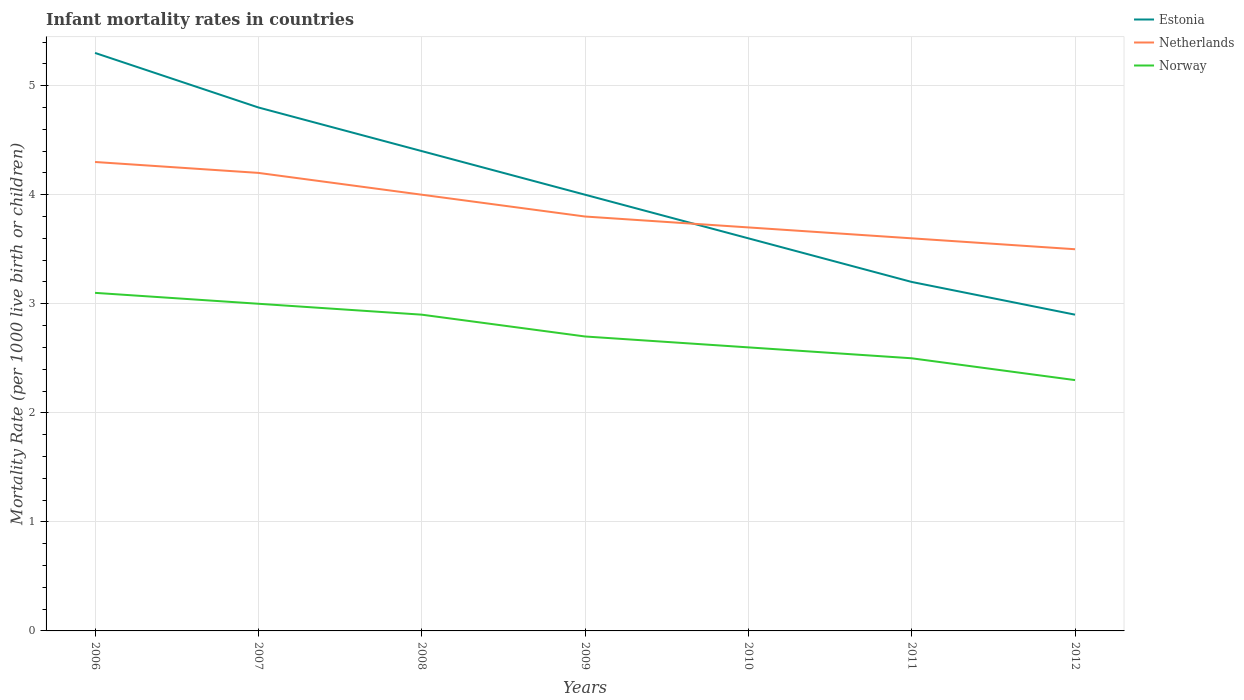How many different coloured lines are there?
Your answer should be very brief. 3. Across all years, what is the maximum infant mortality rate in Norway?
Your answer should be compact. 2.3. What is the total infant mortality rate in Norway in the graph?
Your answer should be compact. 0.2. What is the difference between two consecutive major ticks on the Y-axis?
Provide a succinct answer. 1. What is the title of the graph?
Provide a short and direct response. Infant mortality rates in countries. Does "Korea (Democratic)" appear as one of the legend labels in the graph?
Keep it short and to the point. No. What is the label or title of the X-axis?
Make the answer very short. Years. What is the label or title of the Y-axis?
Your answer should be compact. Mortality Rate (per 1000 live birth or children). What is the Mortality Rate (per 1000 live birth or children) of Estonia in 2006?
Offer a very short reply. 5.3. What is the Mortality Rate (per 1000 live birth or children) of Netherlands in 2006?
Keep it short and to the point. 4.3. What is the Mortality Rate (per 1000 live birth or children) of Estonia in 2007?
Give a very brief answer. 4.8. What is the Mortality Rate (per 1000 live birth or children) of Netherlands in 2007?
Provide a short and direct response. 4.2. What is the Mortality Rate (per 1000 live birth or children) of Netherlands in 2008?
Keep it short and to the point. 4. What is the Mortality Rate (per 1000 live birth or children) of Norway in 2008?
Provide a succinct answer. 2.9. What is the Mortality Rate (per 1000 live birth or children) of Netherlands in 2009?
Keep it short and to the point. 3.8. What is the Mortality Rate (per 1000 live birth or children) in Estonia in 2010?
Offer a terse response. 3.6. What is the Mortality Rate (per 1000 live birth or children) of Netherlands in 2010?
Your answer should be compact. 3.7. What is the Mortality Rate (per 1000 live birth or children) of Norway in 2010?
Provide a short and direct response. 2.6. What is the Mortality Rate (per 1000 live birth or children) in Estonia in 2011?
Provide a succinct answer. 3.2. What is the Mortality Rate (per 1000 live birth or children) in Netherlands in 2012?
Give a very brief answer. 3.5. What is the Mortality Rate (per 1000 live birth or children) in Norway in 2012?
Offer a very short reply. 2.3. Across all years, what is the maximum Mortality Rate (per 1000 live birth or children) in Norway?
Your answer should be very brief. 3.1. Across all years, what is the minimum Mortality Rate (per 1000 live birth or children) of Norway?
Give a very brief answer. 2.3. What is the total Mortality Rate (per 1000 live birth or children) of Estonia in the graph?
Give a very brief answer. 28.2. What is the total Mortality Rate (per 1000 live birth or children) of Netherlands in the graph?
Provide a succinct answer. 27.1. What is the difference between the Mortality Rate (per 1000 live birth or children) of Estonia in 2006 and that in 2007?
Provide a succinct answer. 0.5. What is the difference between the Mortality Rate (per 1000 live birth or children) of Netherlands in 2006 and that in 2007?
Offer a terse response. 0.1. What is the difference between the Mortality Rate (per 1000 live birth or children) in Estonia in 2006 and that in 2008?
Provide a short and direct response. 0.9. What is the difference between the Mortality Rate (per 1000 live birth or children) of Estonia in 2006 and that in 2009?
Give a very brief answer. 1.3. What is the difference between the Mortality Rate (per 1000 live birth or children) of Netherlands in 2006 and that in 2009?
Keep it short and to the point. 0.5. What is the difference between the Mortality Rate (per 1000 live birth or children) in Netherlands in 2006 and that in 2010?
Provide a short and direct response. 0.6. What is the difference between the Mortality Rate (per 1000 live birth or children) in Norway in 2006 and that in 2010?
Your response must be concise. 0.5. What is the difference between the Mortality Rate (per 1000 live birth or children) in Estonia in 2006 and that in 2011?
Ensure brevity in your answer.  2.1. What is the difference between the Mortality Rate (per 1000 live birth or children) in Norway in 2006 and that in 2011?
Provide a short and direct response. 0.6. What is the difference between the Mortality Rate (per 1000 live birth or children) of Norway in 2006 and that in 2012?
Offer a terse response. 0.8. What is the difference between the Mortality Rate (per 1000 live birth or children) of Estonia in 2007 and that in 2008?
Offer a terse response. 0.4. What is the difference between the Mortality Rate (per 1000 live birth or children) of Netherlands in 2007 and that in 2008?
Your response must be concise. 0.2. What is the difference between the Mortality Rate (per 1000 live birth or children) of Norway in 2007 and that in 2008?
Keep it short and to the point. 0.1. What is the difference between the Mortality Rate (per 1000 live birth or children) of Estonia in 2007 and that in 2009?
Your response must be concise. 0.8. What is the difference between the Mortality Rate (per 1000 live birth or children) of Netherlands in 2007 and that in 2009?
Your answer should be very brief. 0.4. What is the difference between the Mortality Rate (per 1000 live birth or children) in Estonia in 2007 and that in 2010?
Offer a very short reply. 1.2. What is the difference between the Mortality Rate (per 1000 live birth or children) in Netherlands in 2007 and that in 2010?
Make the answer very short. 0.5. What is the difference between the Mortality Rate (per 1000 live birth or children) of Netherlands in 2007 and that in 2011?
Your response must be concise. 0.6. What is the difference between the Mortality Rate (per 1000 live birth or children) in Estonia in 2007 and that in 2012?
Ensure brevity in your answer.  1.9. What is the difference between the Mortality Rate (per 1000 live birth or children) of Norway in 2007 and that in 2012?
Your answer should be compact. 0.7. What is the difference between the Mortality Rate (per 1000 live birth or children) of Norway in 2008 and that in 2009?
Your response must be concise. 0.2. What is the difference between the Mortality Rate (per 1000 live birth or children) of Estonia in 2008 and that in 2011?
Your answer should be compact. 1.2. What is the difference between the Mortality Rate (per 1000 live birth or children) in Netherlands in 2008 and that in 2011?
Make the answer very short. 0.4. What is the difference between the Mortality Rate (per 1000 live birth or children) in Norway in 2008 and that in 2011?
Ensure brevity in your answer.  0.4. What is the difference between the Mortality Rate (per 1000 live birth or children) of Estonia in 2008 and that in 2012?
Give a very brief answer. 1.5. What is the difference between the Mortality Rate (per 1000 live birth or children) in Netherlands in 2009 and that in 2010?
Your response must be concise. 0.1. What is the difference between the Mortality Rate (per 1000 live birth or children) of Netherlands in 2009 and that in 2011?
Your response must be concise. 0.2. What is the difference between the Mortality Rate (per 1000 live birth or children) in Norway in 2009 and that in 2011?
Your answer should be compact. 0.2. What is the difference between the Mortality Rate (per 1000 live birth or children) of Estonia in 2009 and that in 2012?
Ensure brevity in your answer.  1.1. What is the difference between the Mortality Rate (per 1000 live birth or children) in Norway in 2009 and that in 2012?
Ensure brevity in your answer.  0.4. What is the difference between the Mortality Rate (per 1000 live birth or children) of Netherlands in 2010 and that in 2011?
Your answer should be compact. 0.1. What is the difference between the Mortality Rate (per 1000 live birth or children) of Estonia in 2010 and that in 2012?
Provide a succinct answer. 0.7. What is the difference between the Mortality Rate (per 1000 live birth or children) in Netherlands in 2010 and that in 2012?
Give a very brief answer. 0.2. What is the difference between the Mortality Rate (per 1000 live birth or children) in Estonia in 2011 and that in 2012?
Your answer should be very brief. 0.3. What is the difference between the Mortality Rate (per 1000 live birth or children) in Netherlands in 2011 and that in 2012?
Give a very brief answer. 0.1. What is the difference between the Mortality Rate (per 1000 live birth or children) of Estonia in 2006 and the Mortality Rate (per 1000 live birth or children) of Netherlands in 2008?
Ensure brevity in your answer.  1.3. What is the difference between the Mortality Rate (per 1000 live birth or children) of Estonia in 2006 and the Mortality Rate (per 1000 live birth or children) of Norway in 2009?
Make the answer very short. 2.6. What is the difference between the Mortality Rate (per 1000 live birth or children) of Netherlands in 2006 and the Mortality Rate (per 1000 live birth or children) of Norway in 2009?
Your response must be concise. 1.6. What is the difference between the Mortality Rate (per 1000 live birth or children) in Estonia in 2006 and the Mortality Rate (per 1000 live birth or children) in Norway in 2010?
Offer a terse response. 2.7. What is the difference between the Mortality Rate (per 1000 live birth or children) in Netherlands in 2006 and the Mortality Rate (per 1000 live birth or children) in Norway in 2010?
Your answer should be compact. 1.7. What is the difference between the Mortality Rate (per 1000 live birth or children) in Estonia in 2006 and the Mortality Rate (per 1000 live birth or children) in Netherlands in 2011?
Keep it short and to the point. 1.7. What is the difference between the Mortality Rate (per 1000 live birth or children) in Netherlands in 2006 and the Mortality Rate (per 1000 live birth or children) in Norway in 2011?
Give a very brief answer. 1.8. What is the difference between the Mortality Rate (per 1000 live birth or children) in Estonia in 2006 and the Mortality Rate (per 1000 live birth or children) in Netherlands in 2012?
Offer a terse response. 1.8. What is the difference between the Mortality Rate (per 1000 live birth or children) in Estonia in 2006 and the Mortality Rate (per 1000 live birth or children) in Norway in 2012?
Provide a succinct answer. 3. What is the difference between the Mortality Rate (per 1000 live birth or children) of Estonia in 2007 and the Mortality Rate (per 1000 live birth or children) of Norway in 2008?
Ensure brevity in your answer.  1.9. What is the difference between the Mortality Rate (per 1000 live birth or children) of Netherlands in 2007 and the Mortality Rate (per 1000 live birth or children) of Norway in 2009?
Your answer should be very brief. 1.5. What is the difference between the Mortality Rate (per 1000 live birth or children) in Estonia in 2007 and the Mortality Rate (per 1000 live birth or children) in Netherlands in 2010?
Provide a short and direct response. 1.1. What is the difference between the Mortality Rate (per 1000 live birth or children) of Estonia in 2007 and the Mortality Rate (per 1000 live birth or children) of Norway in 2010?
Provide a short and direct response. 2.2. What is the difference between the Mortality Rate (per 1000 live birth or children) of Estonia in 2007 and the Mortality Rate (per 1000 live birth or children) of Netherlands in 2011?
Make the answer very short. 1.2. What is the difference between the Mortality Rate (per 1000 live birth or children) of Netherlands in 2007 and the Mortality Rate (per 1000 live birth or children) of Norway in 2011?
Make the answer very short. 1.7. What is the difference between the Mortality Rate (per 1000 live birth or children) in Estonia in 2007 and the Mortality Rate (per 1000 live birth or children) in Netherlands in 2012?
Provide a short and direct response. 1.3. What is the difference between the Mortality Rate (per 1000 live birth or children) in Estonia in 2007 and the Mortality Rate (per 1000 live birth or children) in Norway in 2012?
Provide a short and direct response. 2.5. What is the difference between the Mortality Rate (per 1000 live birth or children) of Netherlands in 2008 and the Mortality Rate (per 1000 live birth or children) of Norway in 2009?
Ensure brevity in your answer.  1.3. What is the difference between the Mortality Rate (per 1000 live birth or children) of Estonia in 2008 and the Mortality Rate (per 1000 live birth or children) of Netherlands in 2010?
Offer a terse response. 0.7. What is the difference between the Mortality Rate (per 1000 live birth or children) of Estonia in 2008 and the Mortality Rate (per 1000 live birth or children) of Norway in 2010?
Make the answer very short. 1.8. What is the difference between the Mortality Rate (per 1000 live birth or children) in Netherlands in 2008 and the Mortality Rate (per 1000 live birth or children) in Norway in 2010?
Offer a terse response. 1.4. What is the difference between the Mortality Rate (per 1000 live birth or children) of Estonia in 2008 and the Mortality Rate (per 1000 live birth or children) of Norway in 2011?
Your response must be concise. 1.9. What is the difference between the Mortality Rate (per 1000 live birth or children) of Netherlands in 2008 and the Mortality Rate (per 1000 live birth or children) of Norway in 2011?
Provide a short and direct response. 1.5. What is the difference between the Mortality Rate (per 1000 live birth or children) in Estonia in 2008 and the Mortality Rate (per 1000 live birth or children) in Netherlands in 2012?
Provide a short and direct response. 0.9. What is the difference between the Mortality Rate (per 1000 live birth or children) in Netherlands in 2008 and the Mortality Rate (per 1000 live birth or children) in Norway in 2012?
Provide a succinct answer. 1.7. What is the difference between the Mortality Rate (per 1000 live birth or children) of Estonia in 2009 and the Mortality Rate (per 1000 live birth or children) of Netherlands in 2011?
Provide a short and direct response. 0.4. What is the difference between the Mortality Rate (per 1000 live birth or children) in Netherlands in 2009 and the Mortality Rate (per 1000 live birth or children) in Norway in 2011?
Keep it short and to the point. 1.3. What is the difference between the Mortality Rate (per 1000 live birth or children) in Estonia in 2009 and the Mortality Rate (per 1000 live birth or children) in Norway in 2012?
Your answer should be very brief. 1.7. What is the difference between the Mortality Rate (per 1000 live birth or children) of Netherlands in 2009 and the Mortality Rate (per 1000 live birth or children) of Norway in 2012?
Offer a terse response. 1.5. What is the difference between the Mortality Rate (per 1000 live birth or children) in Netherlands in 2010 and the Mortality Rate (per 1000 live birth or children) in Norway in 2011?
Ensure brevity in your answer.  1.2. What is the difference between the Mortality Rate (per 1000 live birth or children) of Estonia in 2010 and the Mortality Rate (per 1000 live birth or children) of Netherlands in 2012?
Offer a terse response. 0.1. What is the difference between the Mortality Rate (per 1000 live birth or children) in Netherlands in 2010 and the Mortality Rate (per 1000 live birth or children) in Norway in 2012?
Provide a succinct answer. 1.4. What is the difference between the Mortality Rate (per 1000 live birth or children) of Estonia in 2011 and the Mortality Rate (per 1000 live birth or children) of Norway in 2012?
Ensure brevity in your answer.  0.9. What is the difference between the Mortality Rate (per 1000 live birth or children) of Netherlands in 2011 and the Mortality Rate (per 1000 live birth or children) of Norway in 2012?
Give a very brief answer. 1.3. What is the average Mortality Rate (per 1000 live birth or children) of Estonia per year?
Provide a short and direct response. 4.03. What is the average Mortality Rate (per 1000 live birth or children) in Netherlands per year?
Your response must be concise. 3.87. What is the average Mortality Rate (per 1000 live birth or children) of Norway per year?
Your answer should be compact. 2.73. In the year 2007, what is the difference between the Mortality Rate (per 1000 live birth or children) of Estonia and Mortality Rate (per 1000 live birth or children) of Netherlands?
Provide a succinct answer. 0.6. In the year 2007, what is the difference between the Mortality Rate (per 1000 live birth or children) of Estonia and Mortality Rate (per 1000 live birth or children) of Norway?
Keep it short and to the point. 1.8. In the year 2007, what is the difference between the Mortality Rate (per 1000 live birth or children) in Netherlands and Mortality Rate (per 1000 live birth or children) in Norway?
Ensure brevity in your answer.  1.2. In the year 2008, what is the difference between the Mortality Rate (per 1000 live birth or children) in Estonia and Mortality Rate (per 1000 live birth or children) in Netherlands?
Your answer should be very brief. 0.4. In the year 2008, what is the difference between the Mortality Rate (per 1000 live birth or children) of Estonia and Mortality Rate (per 1000 live birth or children) of Norway?
Your response must be concise. 1.5. In the year 2008, what is the difference between the Mortality Rate (per 1000 live birth or children) in Netherlands and Mortality Rate (per 1000 live birth or children) in Norway?
Your answer should be compact. 1.1. In the year 2010, what is the difference between the Mortality Rate (per 1000 live birth or children) in Netherlands and Mortality Rate (per 1000 live birth or children) in Norway?
Offer a terse response. 1.1. In the year 2011, what is the difference between the Mortality Rate (per 1000 live birth or children) in Estonia and Mortality Rate (per 1000 live birth or children) in Norway?
Offer a very short reply. 0.7. In the year 2011, what is the difference between the Mortality Rate (per 1000 live birth or children) in Netherlands and Mortality Rate (per 1000 live birth or children) in Norway?
Ensure brevity in your answer.  1.1. In the year 2012, what is the difference between the Mortality Rate (per 1000 live birth or children) in Estonia and Mortality Rate (per 1000 live birth or children) in Norway?
Your answer should be very brief. 0.6. What is the ratio of the Mortality Rate (per 1000 live birth or children) in Estonia in 2006 to that in 2007?
Offer a terse response. 1.1. What is the ratio of the Mortality Rate (per 1000 live birth or children) of Netherlands in 2006 to that in 2007?
Keep it short and to the point. 1.02. What is the ratio of the Mortality Rate (per 1000 live birth or children) of Norway in 2006 to that in 2007?
Your answer should be compact. 1.03. What is the ratio of the Mortality Rate (per 1000 live birth or children) in Estonia in 2006 to that in 2008?
Offer a very short reply. 1.2. What is the ratio of the Mortality Rate (per 1000 live birth or children) of Netherlands in 2006 to that in 2008?
Provide a short and direct response. 1.07. What is the ratio of the Mortality Rate (per 1000 live birth or children) of Norway in 2006 to that in 2008?
Offer a terse response. 1.07. What is the ratio of the Mortality Rate (per 1000 live birth or children) in Estonia in 2006 to that in 2009?
Give a very brief answer. 1.32. What is the ratio of the Mortality Rate (per 1000 live birth or children) in Netherlands in 2006 to that in 2009?
Your response must be concise. 1.13. What is the ratio of the Mortality Rate (per 1000 live birth or children) of Norway in 2006 to that in 2009?
Provide a short and direct response. 1.15. What is the ratio of the Mortality Rate (per 1000 live birth or children) of Estonia in 2006 to that in 2010?
Provide a succinct answer. 1.47. What is the ratio of the Mortality Rate (per 1000 live birth or children) in Netherlands in 2006 to that in 2010?
Your answer should be compact. 1.16. What is the ratio of the Mortality Rate (per 1000 live birth or children) of Norway in 2006 to that in 2010?
Provide a succinct answer. 1.19. What is the ratio of the Mortality Rate (per 1000 live birth or children) of Estonia in 2006 to that in 2011?
Offer a terse response. 1.66. What is the ratio of the Mortality Rate (per 1000 live birth or children) of Netherlands in 2006 to that in 2011?
Provide a succinct answer. 1.19. What is the ratio of the Mortality Rate (per 1000 live birth or children) of Norway in 2006 to that in 2011?
Offer a terse response. 1.24. What is the ratio of the Mortality Rate (per 1000 live birth or children) of Estonia in 2006 to that in 2012?
Ensure brevity in your answer.  1.83. What is the ratio of the Mortality Rate (per 1000 live birth or children) in Netherlands in 2006 to that in 2012?
Your response must be concise. 1.23. What is the ratio of the Mortality Rate (per 1000 live birth or children) in Norway in 2006 to that in 2012?
Keep it short and to the point. 1.35. What is the ratio of the Mortality Rate (per 1000 live birth or children) of Netherlands in 2007 to that in 2008?
Ensure brevity in your answer.  1.05. What is the ratio of the Mortality Rate (per 1000 live birth or children) in Norway in 2007 to that in 2008?
Your response must be concise. 1.03. What is the ratio of the Mortality Rate (per 1000 live birth or children) of Estonia in 2007 to that in 2009?
Your answer should be very brief. 1.2. What is the ratio of the Mortality Rate (per 1000 live birth or children) in Netherlands in 2007 to that in 2009?
Provide a short and direct response. 1.11. What is the ratio of the Mortality Rate (per 1000 live birth or children) in Netherlands in 2007 to that in 2010?
Your answer should be compact. 1.14. What is the ratio of the Mortality Rate (per 1000 live birth or children) in Norway in 2007 to that in 2010?
Ensure brevity in your answer.  1.15. What is the ratio of the Mortality Rate (per 1000 live birth or children) of Netherlands in 2007 to that in 2011?
Your response must be concise. 1.17. What is the ratio of the Mortality Rate (per 1000 live birth or children) of Estonia in 2007 to that in 2012?
Give a very brief answer. 1.66. What is the ratio of the Mortality Rate (per 1000 live birth or children) in Netherlands in 2007 to that in 2012?
Provide a short and direct response. 1.2. What is the ratio of the Mortality Rate (per 1000 live birth or children) of Norway in 2007 to that in 2012?
Your answer should be compact. 1.3. What is the ratio of the Mortality Rate (per 1000 live birth or children) of Estonia in 2008 to that in 2009?
Provide a succinct answer. 1.1. What is the ratio of the Mortality Rate (per 1000 live birth or children) in Netherlands in 2008 to that in 2009?
Keep it short and to the point. 1.05. What is the ratio of the Mortality Rate (per 1000 live birth or children) in Norway in 2008 to that in 2009?
Make the answer very short. 1.07. What is the ratio of the Mortality Rate (per 1000 live birth or children) of Estonia in 2008 to that in 2010?
Ensure brevity in your answer.  1.22. What is the ratio of the Mortality Rate (per 1000 live birth or children) of Netherlands in 2008 to that in 2010?
Offer a terse response. 1.08. What is the ratio of the Mortality Rate (per 1000 live birth or children) of Norway in 2008 to that in 2010?
Your response must be concise. 1.12. What is the ratio of the Mortality Rate (per 1000 live birth or children) in Estonia in 2008 to that in 2011?
Keep it short and to the point. 1.38. What is the ratio of the Mortality Rate (per 1000 live birth or children) in Norway in 2008 to that in 2011?
Your answer should be very brief. 1.16. What is the ratio of the Mortality Rate (per 1000 live birth or children) of Estonia in 2008 to that in 2012?
Offer a very short reply. 1.52. What is the ratio of the Mortality Rate (per 1000 live birth or children) in Netherlands in 2008 to that in 2012?
Make the answer very short. 1.14. What is the ratio of the Mortality Rate (per 1000 live birth or children) of Norway in 2008 to that in 2012?
Your answer should be compact. 1.26. What is the ratio of the Mortality Rate (per 1000 live birth or children) in Norway in 2009 to that in 2010?
Provide a short and direct response. 1.04. What is the ratio of the Mortality Rate (per 1000 live birth or children) in Netherlands in 2009 to that in 2011?
Offer a terse response. 1.06. What is the ratio of the Mortality Rate (per 1000 live birth or children) in Estonia in 2009 to that in 2012?
Offer a very short reply. 1.38. What is the ratio of the Mortality Rate (per 1000 live birth or children) in Netherlands in 2009 to that in 2012?
Your answer should be very brief. 1.09. What is the ratio of the Mortality Rate (per 1000 live birth or children) of Norway in 2009 to that in 2012?
Provide a short and direct response. 1.17. What is the ratio of the Mortality Rate (per 1000 live birth or children) of Netherlands in 2010 to that in 2011?
Your response must be concise. 1.03. What is the ratio of the Mortality Rate (per 1000 live birth or children) of Estonia in 2010 to that in 2012?
Your response must be concise. 1.24. What is the ratio of the Mortality Rate (per 1000 live birth or children) in Netherlands in 2010 to that in 2012?
Give a very brief answer. 1.06. What is the ratio of the Mortality Rate (per 1000 live birth or children) of Norway in 2010 to that in 2012?
Ensure brevity in your answer.  1.13. What is the ratio of the Mortality Rate (per 1000 live birth or children) of Estonia in 2011 to that in 2012?
Offer a very short reply. 1.1. What is the ratio of the Mortality Rate (per 1000 live birth or children) of Netherlands in 2011 to that in 2012?
Offer a terse response. 1.03. What is the ratio of the Mortality Rate (per 1000 live birth or children) of Norway in 2011 to that in 2012?
Your answer should be very brief. 1.09. What is the difference between the highest and the second highest Mortality Rate (per 1000 live birth or children) of Netherlands?
Provide a succinct answer. 0.1. What is the difference between the highest and the lowest Mortality Rate (per 1000 live birth or children) in Netherlands?
Give a very brief answer. 0.8. What is the difference between the highest and the lowest Mortality Rate (per 1000 live birth or children) in Norway?
Offer a terse response. 0.8. 